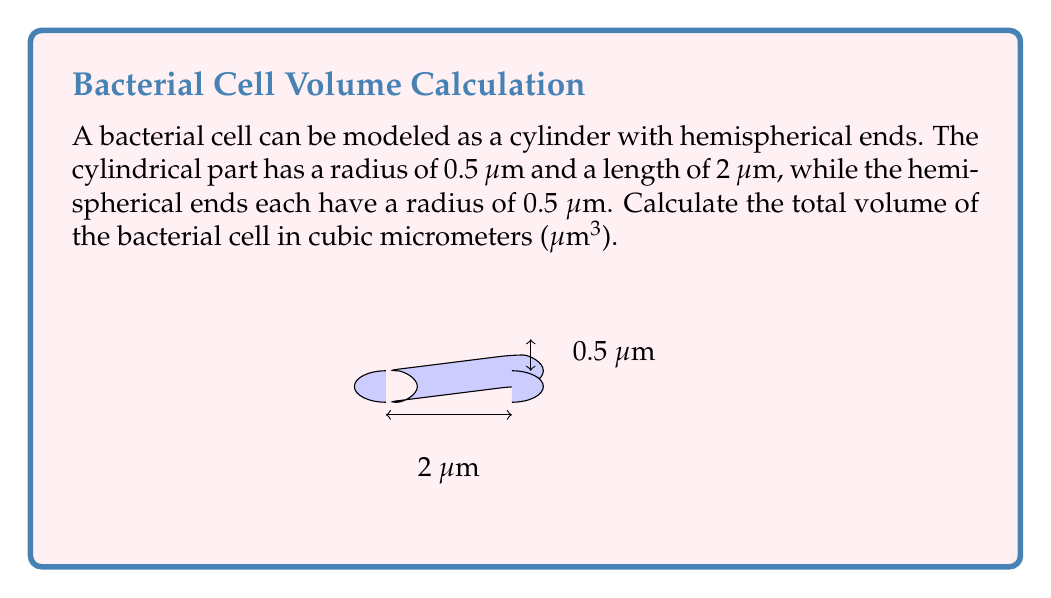Can you solve this math problem? To solve this problem, we need to calculate the volume of the cylindrical part and the two hemispherical ends separately, then sum them up.

1. Volume of the cylindrical part:
   The formula for the volume of a cylinder is $V = \pi r^2 h$
   $$V_{cylinder} = \pi (0.5\text{ μm})^2 (2\text{ μm}) = 0.5\pi\text{ μm}^3$$

2. Volume of the hemispherical ends:
   The formula for the volume of a sphere is $V = \frac{4}{3}\pi r^3$
   For a hemisphere, we use half of this:
   $$V_{hemisphere} = \frac{1}{2} \cdot \frac{4}{3}\pi r^3 = \frac{2}{3}\pi r^3$$
   For each hemisphere:
   $$V_{hemisphere} = \frac{2}{3}\pi (0.5\text{ μm})^3 = \frac{1}{12}\pi\text{ μm}^3$$
   For both hemispheres:
   $$V_{both_hemispheres} = 2 \cdot \frac{1}{12}\pi\text{ μm}^3 = \frac{1}{6}\pi\text{ μm}^3$$

3. Total volume:
   $$V_{total} = V_{cylinder} + V_{both_hemispheres}$$
   $$V_{total} = 0.5\pi\text{ μm}^3 + \frac{1}{6}\pi\text{ μm}^3 = \frac{2}{3}\pi\text{ μm}^3$$

4. Calculating the final value:
   $$V_{total} = \frac{2}{3}\pi\text{ μm}^3 \approx 2.0944\text{ μm}^3$$
Answer: $\frac{2}{3}\pi\text{ μm}^3$ or approximately 2.0944 μm³ 